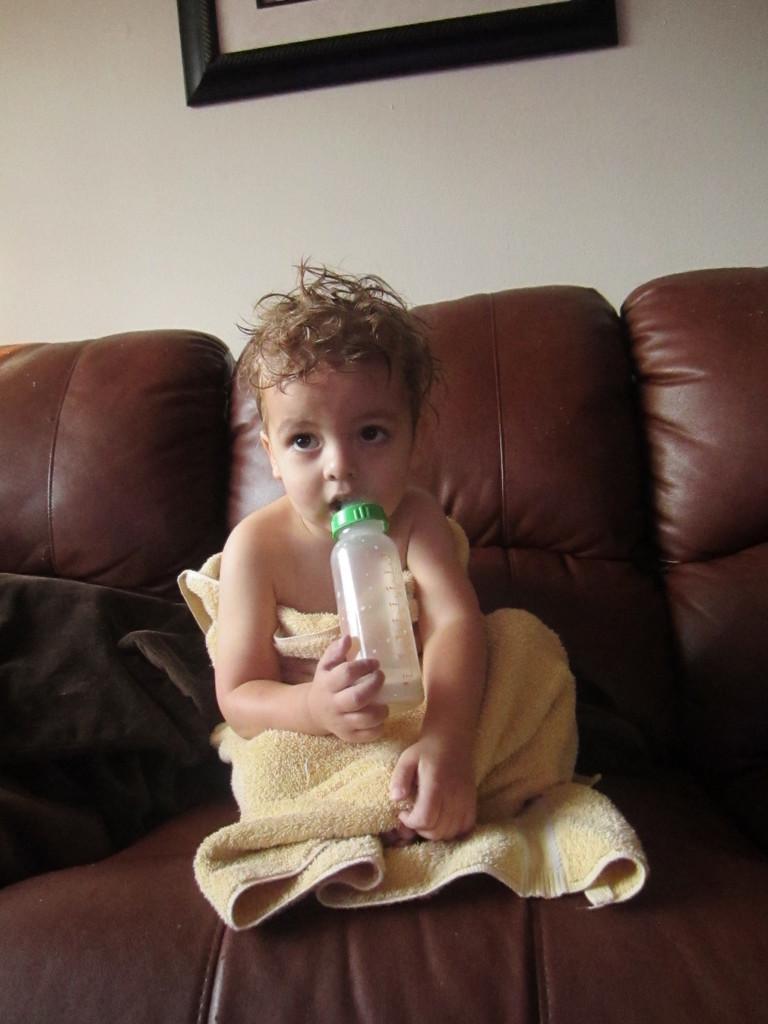Describe this image in one or two sentences. In this image I see a baby who is holding a bottle and sitting on the couch, In the background I see the wall and a photo frame on it. 